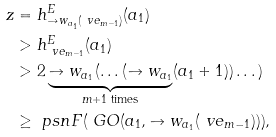Convert formula to latex. <formula><loc_0><loc_0><loc_500><loc_500>z & = h ^ { E } _ { \to w _ { a _ { 1 } } ( \ v e _ { m - 1 } ) } ( a _ { 1 } ) \\ & > h ^ { E } _ { \ v e _ { m - 1 } } ( a _ { 1 } ) \\ & > 2 \underbrace { \to w _ { a _ { 1 } } ( \dots ( \to w _ { a _ { 1 } } } _ { m + 1 \text { times} } ( a _ { 1 } + 1 ) ) \dots ) \\ & \geq \ p s n { F ( \ G O ( a _ { 1 } , \to w _ { a _ { 1 } } ( \ v e _ { m - 1 } ) ) ) } ,</formula> 